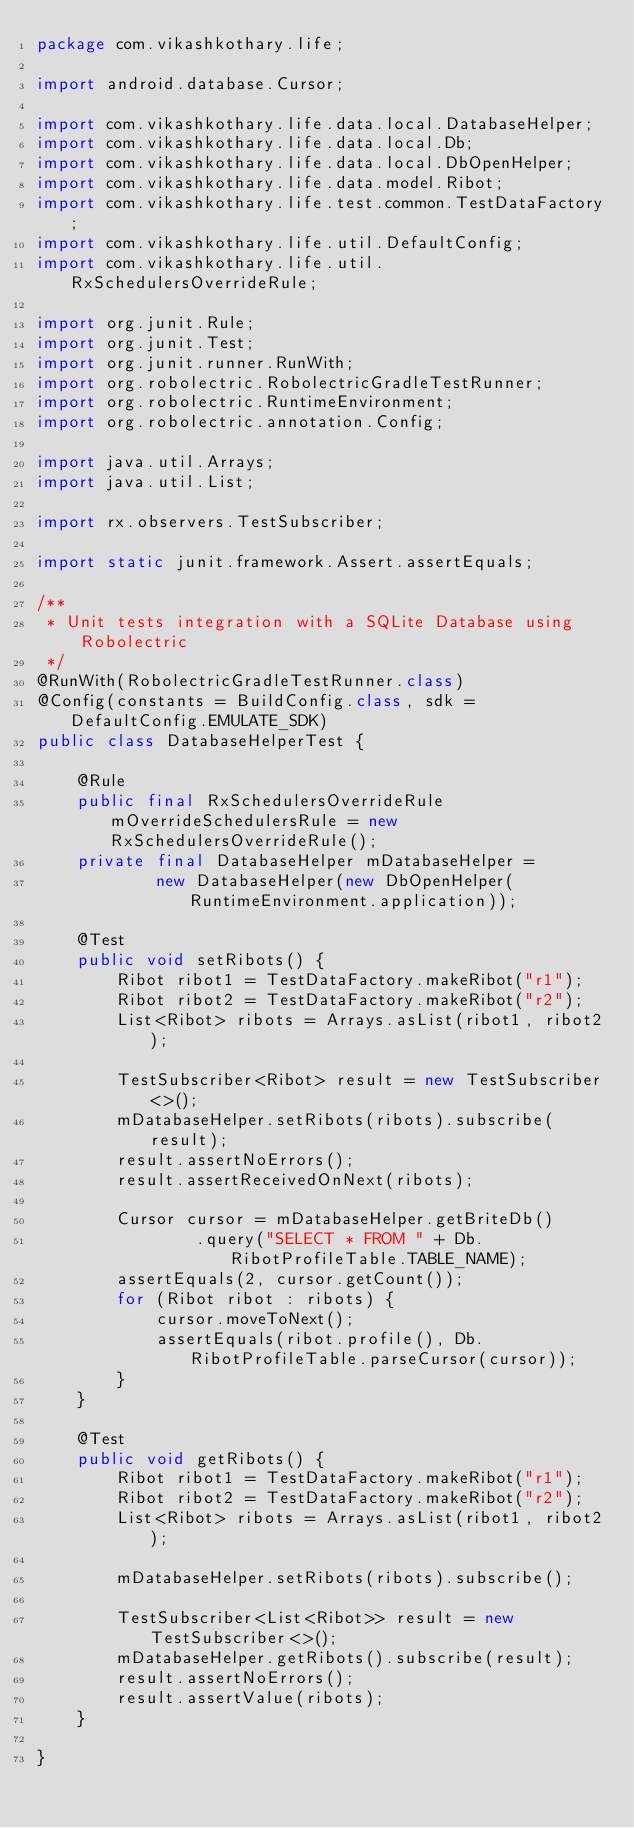<code> <loc_0><loc_0><loc_500><loc_500><_Java_>package com.vikashkothary.life;

import android.database.Cursor;

import com.vikashkothary.life.data.local.DatabaseHelper;
import com.vikashkothary.life.data.local.Db;
import com.vikashkothary.life.data.local.DbOpenHelper;
import com.vikashkothary.life.data.model.Ribot;
import com.vikashkothary.life.test.common.TestDataFactory;
import com.vikashkothary.life.util.DefaultConfig;
import com.vikashkothary.life.util.RxSchedulersOverrideRule;

import org.junit.Rule;
import org.junit.Test;
import org.junit.runner.RunWith;
import org.robolectric.RobolectricGradleTestRunner;
import org.robolectric.RuntimeEnvironment;
import org.robolectric.annotation.Config;

import java.util.Arrays;
import java.util.List;

import rx.observers.TestSubscriber;

import static junit.framework.Assert.assertEquals;

/**
 * Unit tests integration with a SQLite Database using Robolectric
 */
@RunWith(RobolectricGradleTestRunner.class)
@Config(constants = BuildConfig.class, sdk = DefaultConfig.EMULATE_SDK)
public class DatabaseHelperTest {

    @Rule
    public final RxSchedulersOverrideRule mOverrideSchedulersRule = new RxSchedulersOverrideRule();
    private final DatabaseHelper mDatabaseHelper =
            new DatabaseHelper(new DbOpenHelper(RuntimeEnvironment.application));

    @Test
    public void setRibots() {
        Ribot ribot1 = TestDataFactory.makeRibot("r1");
        Ribot ribot2 = TestDataFactory.makeRibot("r2");
        List<Ribot> ribots = Arrays.asList(ribot1, ribot2);

        TestSubscriber<Ribot> result = new TestSubscriber<>();
        mDatabaseHelper.setRibots(ribots).subscribe(result);
        result.assertNoErrors();
        result.assertReceivedOnNext(ribots);

        Cursor cursor = mDatabaseHelper.getBriteDb()
                .query("SELECT * FROM " + Db.RibotProfileTable.TABLE_NAME);
        assertEquals(2, cursor.getCount());
        for (Ribot ribot : ribots) {
            cursor.moveToNext();
            assertEquals(ribot.profile(), Db.RibotProfileTable.parseCursor(cursor));
        }
    }

    @Test
    public void getRibots() {
        Ribot ribot1 = TestDataFactory.makeRibot("r1");
        Ribot ribot2 = TestDataFactory.makeRibot("r2");
        List<Ribot> ribots = Arrays.asList(ribot1, ribot2);

        mDatabaseHelper.setRibots(ribots).subscribe();

        TestSubscriber<List<Ribot>> result = new TestSubscriber<>();
        mDatabaseHelper.getRibots().subscribe(result);
        result.assertNoErrors();
        result.assertValue(ribots);
    }

}</code> 